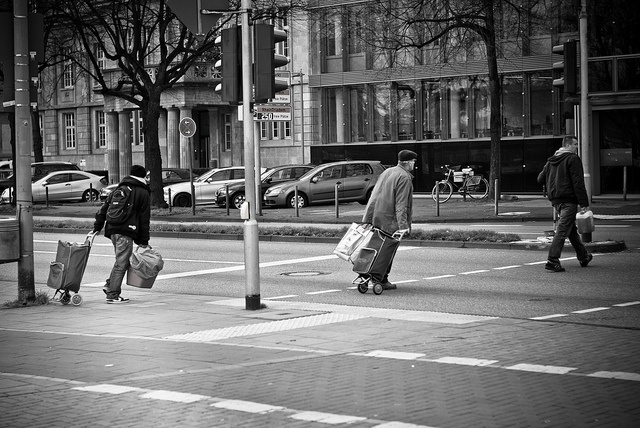Describe the objects in this image and their specific colors. I can see people in black, gray, darkgray, and lightgray tones, people in black, gray, darkgray, and lightgray tones, car in black, gray, darkgray, and lightgray tones, people in black, gray, darkgray, and lightgray tones, and car in black, gray, lightgray, and darkgray tones in this image. 